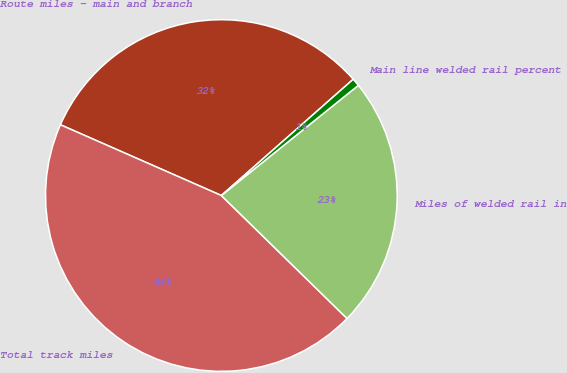<chart> <loc_0><loc_0><loc_500><loc_500><pie_chart><fcel>Route miles - main and branch<fcel>Total track miles<fcel>Miles of welded rail in<fcel>Main line welded rail percent<nl><fcel>31.91%<fcel>44.27%<fcel>23.11%<fcel>0.72%<nl></chart> 